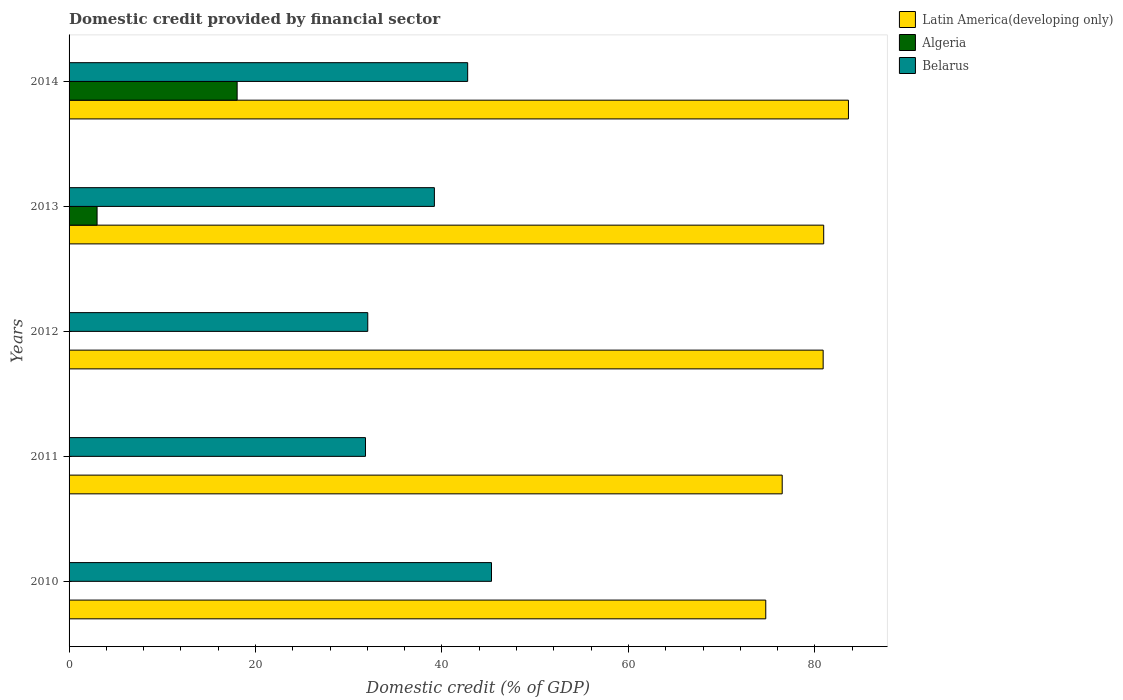How many different coloured bars are there?
Offer a terse response. 3. How many groups of bars are there?
Give a very brief answer. 5. How many bars are there on the 5th tick from the top?
Keep it short and to the point. 2. How many bars are there on the 5th tick from the bottom?
Your answer should be very brief. 3. What is the domestic credit in Latin America(developing only) in 2012?
Your response must be concise. 80.88. Across all years, what is the maximum domestic credit in Belarus?
Ensure brevity in your answer.  45.31. Across all years, what is the minimum domestic credit in Belarus?
Offer a terse response. 31.79. What is the total domestic credit in Latin America(developing only) in the graph?
Keep it short and to the point. 396.65. What is the difference between the domestic credit in Belarus in 2010 and that in 2012?
Your answer should be compact. 13.27. What is the difference between the domestic credit in Latin America(developing only) in 2010 and the domestic credit in Algeria in 2012?
Make the answer very short. 74.73. What is the average domestic credit in Latin America(developing only) per year?
Offer a terse response. 79.33. In the year 2011, what is the difference between the domestic credit in Belarus and domestic credit in Latin America(developing only)?
Provide a succinct answer. -44.7. What is the ratio of the domestic credit in Algeria in 2013 to that in 2014?
Provide a succinct answer. 0.17. Is the domestic credit in Latin America(developing only) in 2012 less than that in 2013?
Keep it short and to the point. Yes. What is the difference between the highest and the second highest domestic credit in Belarus?
Offer a terse response. 2.56. What is the difference between the highest and the lowest domestic credit in Algeria?
Make the answer very short. 18.03. Is the sum of the domestic credit in Latin America(developing only) in 2012 and 2013 greater than the maximum domestic credit in Belarus across all years?
Your response must be concise. Yes. Are all the bars in the graph horizontal?
Provide a succinct answer. Yes. How many years are there in the graph?
Your answer should be very brief. 5. What is the difference between two consecutive major ticks on the X-axis?
Make the answer very short. 20. Are the values on the major ticks of X-axis written in scientific E-notation?
Your response must be concise. No. Does the graph contain any zero values?
Provide a succinct answer. Yes. Does the graph contain grids?
Make the answer very short. No. Where does the legend appear in the graph?
Your answer should be very brief. Top right. How are the legend labels stacked?
Ensure brevity in your answer.  Vertical. What is the title of the graph?
Ensure brevity in your answer.  Domestic credit provided by financial sector. Does "Bangladesh" appear as one of the legend labels in the graph?
Offer a very short reply. No. What is the label or title of the X-axis?
Your answer should be compact. Domestic credit (% of GDP). What is the label or title of the Y-axis?
Offer a terse response. Years. What is the Domestic credit (% of GDP) of Latin America(developing only) in 2010?
Your response must be concise. 74.73. What is the Domestic credit (% of GDP) of Belarus in 2010?
Provide a short and direct response. 45.31. What is the Domestic credit (% of GDP) in Latin America(developing only) in 2011?
Provide a short and direct response. 76.49. What is the Domestic credit (% of GDP) in Algeria in 2011?
Keep it short and to the point. 0. What is the Domestic credit (% of GDP) in Belarus in 2011?
Ensure brevity in your answer.  31.79. What is the Domestic credit (% of GDP) in Latin America(developing only) in 2012?
Make the answer very short. 80.88. What is the Domestic credit (% of GDP) in Algeria in 2012?
Offer a very short reply. 0. What is the Domestic credit (% of GDP) in Belarus in 2012?
Give a very brief answer. 32.04. What is the Domestic credit (% of GDP) of Latin America(developing only) in 2013?
Provide a short and direct response. 80.94. What is the Domestic credit (% of GDP) in Algeria in 2013?
Provide a short and direct response. 3. What is the Domestic credit (% of GDP) of Belarus in 2013?
Provide a short and direct response. 39.18. What is the Domestic credit (% of GDP) in Latin America(developing only) in 2014?
Your answer should be very brief. 83.6. What is the Domestic credit (% of GDP) of Algeria in 2014?
Give a very brief answer. 18.03. What is the Domestic credit (% of GDP) of Belarus in 2014?
Your response must be concise. 42.76. Across all years, what is the maximum Domestic credit (% of GDP) in Latin America(developing only)?
Provide a succinct answer. 83.6. Across all years, what is the maximum Domestic credit (% of GDP) of Algeria?
Give a very brief answer. 18.03. Across all years, what is the maximum Domestic credit (% of GDP) of Belarus?
Offer a very short reply. 45.31. Across all years, what is the minimum Domestic credit (% of GDP) of Latin America(developing only)?
Ensure brevity in your answer.  74.73. Across all years, what is the minimum Domestic credit (% of GDP) in Algeria?
Make the answer very short. 0. Across all years, what is the minimum Domestic credit (% of GDP) in Belarus?
Offer a terse response. 31.79. What is the total Domestic credit (% of GDP) of Latin America(developing only) in the graph?
Your answer should be very brief. 396.65. What is the total Domestic credit (% of GDP) of Algeria in the graph?
Offer a terse response. 21.03. What is the total Domestic credit (% of GDP) in Belarus in the graph?
Offer a terse response. 191.08. What is the difference between the Domestic credit (% of GDP) in Latin America(developing only) in 2010 and that in 2011?
Your response must be concise. -1.76. What is the difference between the Domestic credit (% of GDP) in Belarus in 2010 and that in 2011?
Offer a very short reply. 13.52. What is the difference between the Domestic credit (% of GDP) in Latin America(developing only) in 2010 and that in 2012?
Provide a succinct answer. -6.15. What is the difference between the Domestic credit (% of GDP) of Belarus in 2010 and that in 2012?
Your response must be concise. 13.27. What is the difference between the Domestic credit (% of GDP) of Latin America(developing only) in 2010 and that in 2013?
Your answer should be very brief. -6.21. What is the difference between the Domestic credit (% of GDP) of Belarus in 2010 and that in 2013?
Your response must be concise. 6.13. What is the difference between the Domestic credit (% of GDP) of Latin America(developing only) in 2010 and that in 2014?
Make the answer very short. -8.87. What is the difference between the Domestic credit (% of GDP) of Belarus in 2010 and that in 2014?
Make the answer very short. 2.56. What is the difference between the Domestic credit (% of GDP) of Latin America(developing only) in 2011 and that in 2012?
Offer a terse response. -4.39. What is the difference between the Domestic credit (% of GDP) in Belarus in 2011 and that in 2012?
Make the answer very short. -0.25. What is the difference between the Domestic credit (% of GDP) of Latin America(developing only) in 2011 and that in 2013?
Your answer should be very brief. -4.45. What is the difference between the Domestic credit (% of GDP) in Belarus in 2011 and that in 2013?
Provide a succinct answer. -7.39. What is the difference between the Domestic credit (% of GDP) of Latin America(developing only) in 2011 and that in 2014?
Keep it short and to the point. -7.1. What is the difference between the Domestic credit (% of GDP) of Belarus in 2011 and that in 2014?
Your answer should be compact. -10.96. What is the difference between the Domestic credit (% of GDP) in Latin America(developing only) in 2012 and that in 2013?
Give a very brief answer. -0.06. What is the difference between the Domestic credit (% of GDP) in Belarus in 2012 and that in 2013?
Your response must be concise. -7.15. What is the difference between the Domestic credit (% of GDP) in Latin America(developing only) in 2012 and that in 2014?
Your answer should be very brief. -2.71. What is the difference between the Domestic credit (% of GDP) of Belarus in 2012 and that in 2014?
Your answer should be very brief. -10.72. What is the difference between the Domestic credit (% of GDP) of Latin America(developing only) in 2013 and that in 2014?
Keep it short and to the point. -2.65. What is the difference between the Domestic credit (% of GDP) of Algeria in 2013 and that in 2014?
Keep it short and to the point. -15.02. What is the difference between the Domestic credit (% of GDP) in Belarus in 2013 and that in 2014?
Your answer should be compact. -3.57. What is the difference between the Domestic credit (% of GDP) in Latin America(developing only) in 2010 and the Domestic credit (% of GDP) in Belarus in 2011?
Offer a very short reply. 42.94. What is the difference between the Domestic credit (% of GDP) in Latin America(developing only) in 2010 and the Domestic credit (% of GDP) in Belarus in 2012?
Provide a succinct answer. 42.69. What is the difference between the Domestic credit (% of GDP) of Latin America(developing only) in 2010 and the Domestic credit (% of GDP) of Algeria in 2013?
Ensure brevity in your answer.  71.73. What is the difference between the Domestic credit (% of GDP) in Latin America(developing only) in 2010 and the Domestic credit (% of GDP) in Belarus in 2013?
Make the answer very short. 35.55. What is the difference between the Domestic credit (% of GDP) of Latin America(developing only) in 2010 and the Domestic credit (% of GDP) of Algeria in 2014?
Your answer should be compact. 56.7. What is the difference between the Domestic credit (% of GDP) in Latin America(developing only) in 2010 and the Domestic credit (% of GDP) in Belarus in 2014?
Make the answer very short. 31.97. What is the difference between the Domestic credit (% of GDP) of Latin America(developing only) in 2011 and the Domestic credit (% of GDP) of Belarus in 2012?
Your answer should be compact. 44.45. What is the difference between the Domestic credit (% of GDP) of Latin America(developing only) in 2011 and the Domestic credit (% of GDP) of Algeria in 2013?
Provide a short and direct response. 73.49. What is the difference between the Domestic credit (% of GDP) of Latin America(developing only) in 2011 and the Domestic credit (% of GDP) of Belarus in 2013?
Provide a short and direct response. 37.31. What is the difference between the Domestic credit (% of GDP) of Latin America(developing only) in 2011 and the Domestic credit (% of GDP) of Algeria in 2014?
Keep it short and to the point. 58.47. What is the difference between the Domestic credit (% of GDP) in Latin America(developing only) in 2011 and the Domestic credit (% of GDP) in Belarus in 2014?
Give a very brief answer. 33.74. What is the difference between the Domestic credit (% of GDP) of Latin America(developing only) in 2012 and the Domestic credit (% of GDP) of Algeria in 2013?
Ensure brevity in your answer.  77.88. What is the difference between the Domestic credit (% of GDP) of Latin America(developing only) in 2012 and the Domestic credit (% of GDP) of Belarus in 2013?
Give a very brief answer. 41.7. What is the difference between the Domestic credit (% of GDP) of Latin America(developing only) in 2012 and the Domestic credit (% of GDP) of Algeria in 2014?
Keep it short and to the point. 62.86. What is the difference between the Domestic credit (% of GDP) in Latin America(developing only) in 2012 and the Domestic credit (% of GDP) in Belarus in 2014?
Provide a succinct answer. 38.13. What is the difference between the Domestic credit (% of GDP) of Latin America(developing only) in 2013 and the Domestic credit (% of GDP) of Algeria in 2014?
Provide a succinct answer. 62.92. What is the difference between the Domestic credit (% of GDP) in Latin America(developing only) in 2013 and the Domestic credit (% of GDP) in Belarus in 2014?
Offer a very short reply. 38.19. What is the difference between the Domestic credit (% of GDP) in Algeria in 2013 and the Domestic credit (% of GDP) in Belarus in 2014?
Your response must be concise. -39.75. What is the average Domestic credit (% of GDP) in Latin America(developing only) per year?
Offer a terse response. 79.33. What is the average Domestic credit (% of GDP) of Algeria per year?
Your answer should be very brief. 4.21. What is the average Domestic credit (% of GDP) of Belarus per year?
Your answer should be compact. 38.22. In the year 2010, what is the difference between the Domestic credit (% of GDP) in Latin America(developing only) and Domestic credit (% of GDP) in Belarus?
Provide a short and direct response. 29.42. In the year 2011, what is the difference between the Domestic credit (% of GDP) in Latin America(developing only) and Domestic credit (% of GDP) in Belarus?
Provide a succinct answer. 44.7. In the year 2012, what is the difference between the Domestic credit (% of GDP) of Latin America(developing only) and Domestic credit (% of GDP) of Belarus?
Provide a short and direct response. 48.85. In the year 2013, what is the difference between the Domestic credit (% of GDP) in Latin America(developing only) and Domestic credit (% of GDP) in Algeria?
Keep it short and to the point. 77.94. In the year 2013, what is the difference between the Domestic credit (% of GDP) of Latin America(developing only) and Domestic credit (% of GDP) of Belarus?
Offer a terse response. 41.76. In the year 2013, what is the difference between the Domestic credit (% of GDP) of Algeria and Domestic credit (% of GDP) of Belarus?
Provide a succinct answer. -36.18. In the year 2014, what is the difference between the Domestic credit (% of GDP) in Latin America(developing only) and Domestic credit (% of GDP) in Algeria?
Your response must be concise. 65.57. In the year 2014, what is the difference between the Domestic credit (% of GDP) in Latin America(developing only) and Domestic credit (% of GDP) in Belarus?
Your response must be concise. 40.84. In the year 2014, what is the difference between the Domestic credit (% of GDP) of Algeria and Domestic credit (% of GDP) of Belarus?
Offer a very short reply. -24.73. What is the ratio of the Domestic credit (% of GDP) in Belarus in 2010 to that in 2011?
Make the answer very short. 1.43. What is the ratio of the Domestic credit (% of GDP) in Latin America(developing only) in 2010 to that in 2012?
Give a very brief answer. 0.92. What is the ratio of the Domestic credit (% of GDP) in Belarus in 2010 to that in 2012?
Your response must be concise. 1.41. What is the ratio of the Domestic credit (% of GDP) in Latin America(developing only) in 2010 to that in 2013?
Offer a very short reply. 0.92. What is the ratio of the Domestic credit (% of GDP) in Belarus in 2010 to that in 2013?
Ensure brevity in your answer.  1.16. What is the ratio of the Domestic credit (% of GDP) in Latin America(developing only) in 2010 to that in 2014?
Your answer should be very brief. 0.89. What is the ratio of the Domestic credit (% of GDP) in Belarus in 2010 to that in 2014?
Keep it short and to the point. 1.06. What is the ratio of the Domestic credit (% of GDP) in Latin America(developing only) in 2011 to that in 2012?
Offer a terse response. 0.95. What is the ratio of the Domestic credit (% of GDP) in Belarus in 2011 to that in 2012?
Your answer should be compact. 0.99. What is the ratio of the Domestic credit (% of GDP) in Latin America(developing only) in 2011 to that in 2013?
Provide a succinct answer. 0.94. What is the ratio of the Domestic credit (% of GDP) in Belarus in 2011 to that in 2013?
Your answer should be compact. 0.81. What is the ratio of the Domestic credit (% of GDP) of Latin America(developing only) in 2011 to that in 2014?
Your answer should be compact. 0.92. What is the ratio of the Domestic credit (% of GDP) of Belarus in 2011 to that in 2014?
Your response must be concise. 0.74. What is the ratio of the Domestic credit (% of GDP) in Latin America(developing only) in 2012 to that in 2013?
Make the answer very short. 1. What is the ratio of the Domestic credit (% of GDP) in Belarus in 2012 to that in 2013?
Provide a succinct answer. 0.82. What is the ratio of the Domestic credit (% of GDP) of Latin America(developing only) in 2012 to that in 2014?
Your answer should be compact. 0.97. What is the ratio of the Domestic credit (% of GDP) in Belarus in 2012 to that in 2014?
Give a very brief answer. 0.75. What is the ratio of the Domestic credit (% of GDP) in Latin America(developing only) in 2013 to that in 2014?
Your response must be concise. 0.97. What is the ratio of the Domestic credit (% of GDP) of Algeria in 2013 to that in 2014?
Offer a very short reply. 0.17. What is the ratio of the Domestic credit (% of GDP) of Belarus in 2013 to that in 2014?
Keep it short and to the point. 0.92. What is the difference between the highest and the second highest Domestic credit (% of GDP) of Latin America(developing only)?
Offer a very short reply. 2.65. What is the difference between the highest and the second highest Domestic credit (% of GDP) in Belarus?
Your response must be concise. 2.56. What is the difference between the highest and the lowest Domestic credit (% of GDP) in Latin America(developing only)?
Your response must be concise. 8.87. What is the difference between the highest and the lowest Domestic credit (% of GDP) in Algeria?
Your answer should be very brief. 18.03. What is the difference between the highest and the lowest Domestic credit (% of GDP) of Belarus?
Offer a terse response. 13.52. 